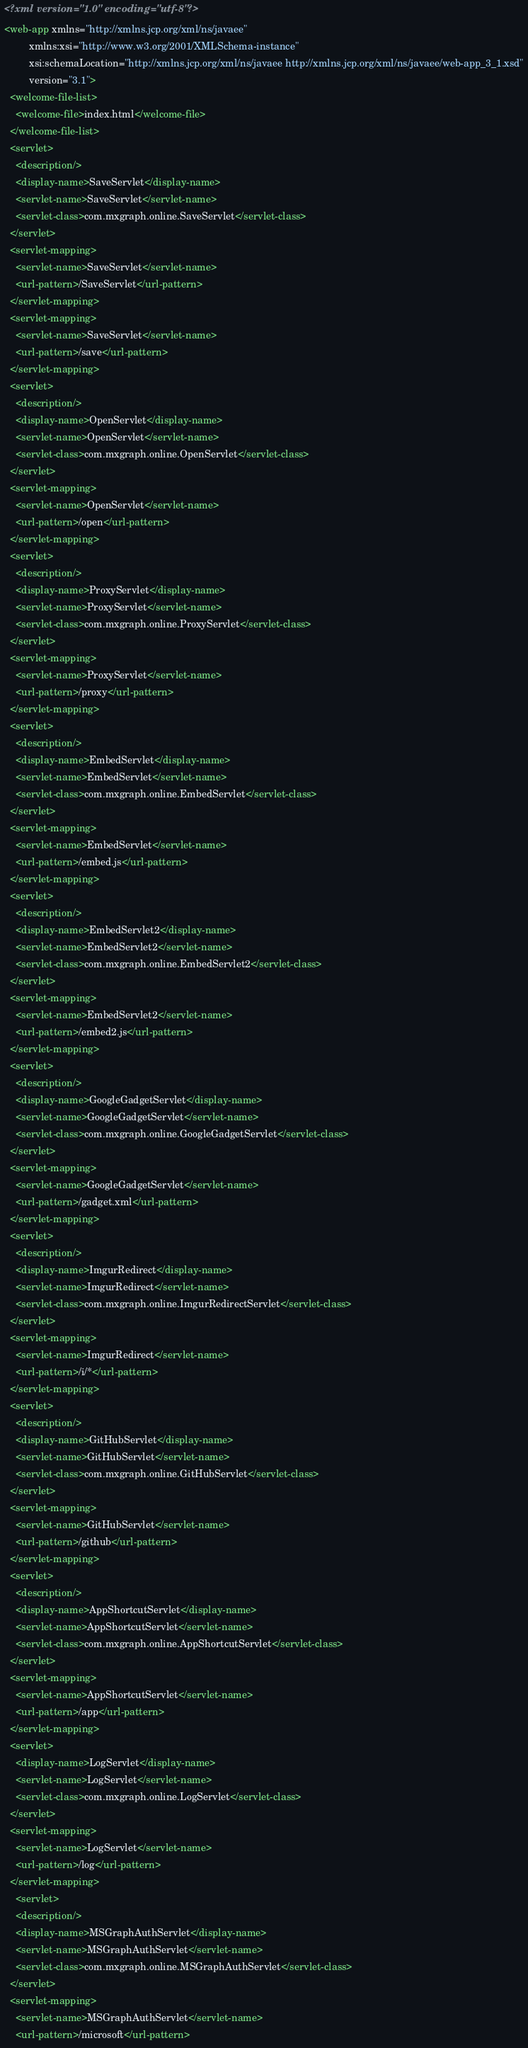Convert code to text. <code><loc_0><loc_0><loc_500><loc_500><_XML_><?xml version="1.0" encoding="utf-8"?>
<web-app xmlns="http://xmlns.jcp.org/xml/ns/javaee"
         xmlns:xsi="http://www.w3.org/2001/XMLSchema-instance"
         xsi:schemaLocation="http://xmlns.jcp.org/xml/ns/javaee http://xmlns.jcp.org/xml/ns/javaee/web-app_3_1.xsd"
         version="3.1">
  <welcome-file-list>
    <welcome-file>index.html</welcome-file>
  </welcome-file-list>
  <servlet>
    <description/>
    <display-name>SaveServlet</display-name>
    <servlet-name>SaveServlet</servlet-name>
    <servlet-class>com.mxgraph.online.SaveServlet</servlet-class>
  </servlet>
  <servlet-mapping>
    <servlet-name>SaveServlet</servlet-name>
    <url-pattern>/SaveServlet</url-pattern>
  </servlet-mapping>
  <servlet-mapping>
    <servlet-name>SaveServlet</servlet-name>
    <url-pattern>/save</url-pattern>
  </servlet-mapping>
  <servlet>
    <description/>
    <display-name>OpenServlet</display-name>
    <servlet-name>OpenServlet</servlet-name>
    <servlet-class>com.mxgraph.online.OpenServlet</servlet-class>
  </servlet>
  <servlet-mapping>
    <servlet-name>OpenServlet</servlet-name>
    <url-pattern>/open</url-pattern>
  </servlet-mapping>
  <servlet>
    <description/>
    <display-name>ProxyServlet</display-name>
    <servlet-name>ProxyServlet</servlet-name>
    <servlet-class>com.mxgraph.online.ProxyServlet</servlet-class>
  </servlet>
  <servlet-mapping>
    <servlet-name>ProxyServlet</servlet-name>
    <url-pattern>/proxy</url-pattern>
  </servlet-mapping>
  <servlet>
    <description/>
    <display-name>EmbedServlet</display-name>
    <servlet-name>EmbedServlet</servlet-name>
    <servlet-class>com.mxgraph.online.EmbedServlet</servlet-class>
  </servlet>
  <servlet-mapping>
    <servlet-name>EmbedServlet</servlet-name>
    <url-pattern>/embed.js</url-pattern>
  </servlet-mapping>
  <servlet>
    <description/>
    <display-name>EmbedServlet2</display-name>
    <servlet-name>EmbedServlet2</servlet-name>
    <servlet-class>com.mxgraph.online.EmbedServlet2</servlet-class>
  </servlet>
  <servlet-mapping>
    <servlet-name>EmbedServlet2</servlet-name>
    <url-pattern>/embed2.js</url-pattern>
  </servlet-mapping>
  <servlet>
    <description/>
    <display-name>GoogleGadgetServlet</display-name>
    <servlet-name>GoogleGadgetServlet</servlet-name>
    <servlet-class>com.mxgraph.online.GoogleGadgetServlet</servlet-class>
  </servlet>
  <servlet-mapping>
    <servlet-name>GoogleGadgetServlet</servlet-name>
    <url-pattern>/gadget.xml</url-pattern>
  </servlet-mapping>
  <servlet>
    <description/>
    <display-name>ImgurRedirect</display-name>
    <servlet-name>ImgurRedirect</servlet-name>
    <servlet-class>com.mxgraph.online.ImgurRedirectServlet</servlet-class>
  </servlet>
  <servlet-mapping>
    <servlet-name>ImgurRedirect</servlet-name>
    <url-pattern>/i/*</url-pattern>
  </servlet-mapping>
  <servlet>
    <description/>
    <display-name>GitHubServlet</display-name>
    <servlet-name>GitHubServlet</servlet-name>
    <servlet-class>com.mxgraph.online.GitHubServlet</servlet-class>
  </servlet>
  <servlet-mapping>
    <servlet-name>GitHubServlet</servlet-name>
    <url-pattern>/github</url-pattern>
  </servlet-mapping>
  <servlet>
    <description/>
    <display-name>AppShortcutServlet</display-name>
    <servlet-name>AppShortcutServlet</servlet-name>
    <servlet-class>com.mxgraph.online.AppShortcutServlet</servlet-class>
  </servlet>
  <servlet-mapping>
    <servlet-name>AppShortcutServlet</servlet-name>
    <url-pattern>/app</url-pattern>
  </servlet-mapping>
  <servlet>
    <display-name>LogServlet</display-name>
    <servlet-name>LogServlet</servlet-name>
    <servlet-class>com.mxgraph.online.LogServlet</servlet-class>
  </servlet>
  <servlet-mapping>
    <servlet-name>LogServlet</servlet-name>
    <url-pattern>/log</url-pattern>
  </servlet-mapping>
    <servlet>
    <description/>
    <display-name>MSGraphAuthServlet</display-name>
    <servlet-name>MSGraphAuthServlet</servlet-name>
    <servlet-class>com.mxgraph.online.MSGraphAuthServlet</servlet-class>
  </servlet>
  <servlet-mapping>
    <servlet-name>MSGraphAuthServlet</servlet-name>
    <url-pattern>/microsoft</url-pattern></code> 